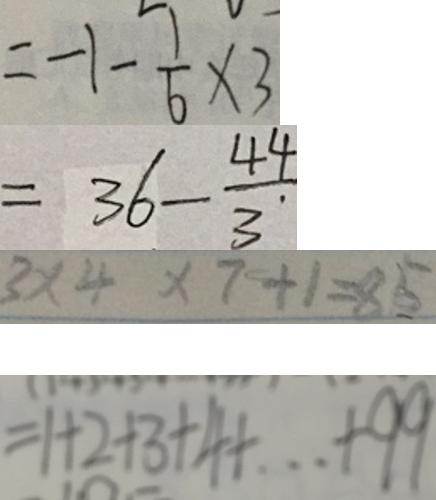<formula> <loc_0><loc_0><loc_500><loc_500>= - 1 - \frac { 1 } { 6 } \times 3 
 = 3 6 - \frac { 4 4 } { 3 . } 
 3 \times 4 \times 7 + 1 = 8 5 
 = 1 + 2 + 3 + 4 + \cdots + 9 9</formula> 